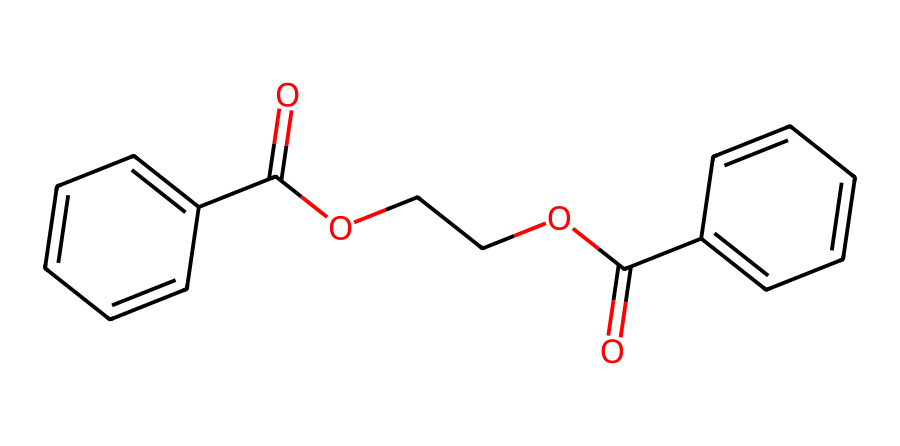What type of chemical is represented by this SMILES? The SMILES indicates that this is an ester due to the presence of the -COO- functional group, which is characteristic of esters.
Answer: ester How many rings are present in the structure? Upon analyzing the structure, there are two aromatic rings evident from the notation, which includes two instances of 'c' indicating carbon atoms in rings.
Answer: two What is the common usage of this chemical? This compound is specifically noted for its application in polyester fibers, which are used in various textiles, including flags.
Answer: textiles How many carbon atoms are in the structure? By counting the 'c' and 'C' symbols in the SMILES, there are 14 carbon atoms total present in the structure.
Answer: fourteen What functional groups are present in this chemical? The structure contains ester groups (-COO-) and aromatic rings, indicating its dual functional nature as a polyester fiber.
Answer: ester and aromatic Is this chemical biodegradable? Generally, polyesters are not readily biodegradable, but this specific structure might have varying rates of biodegradation depending on the side chains and overall design.
Answer: no 